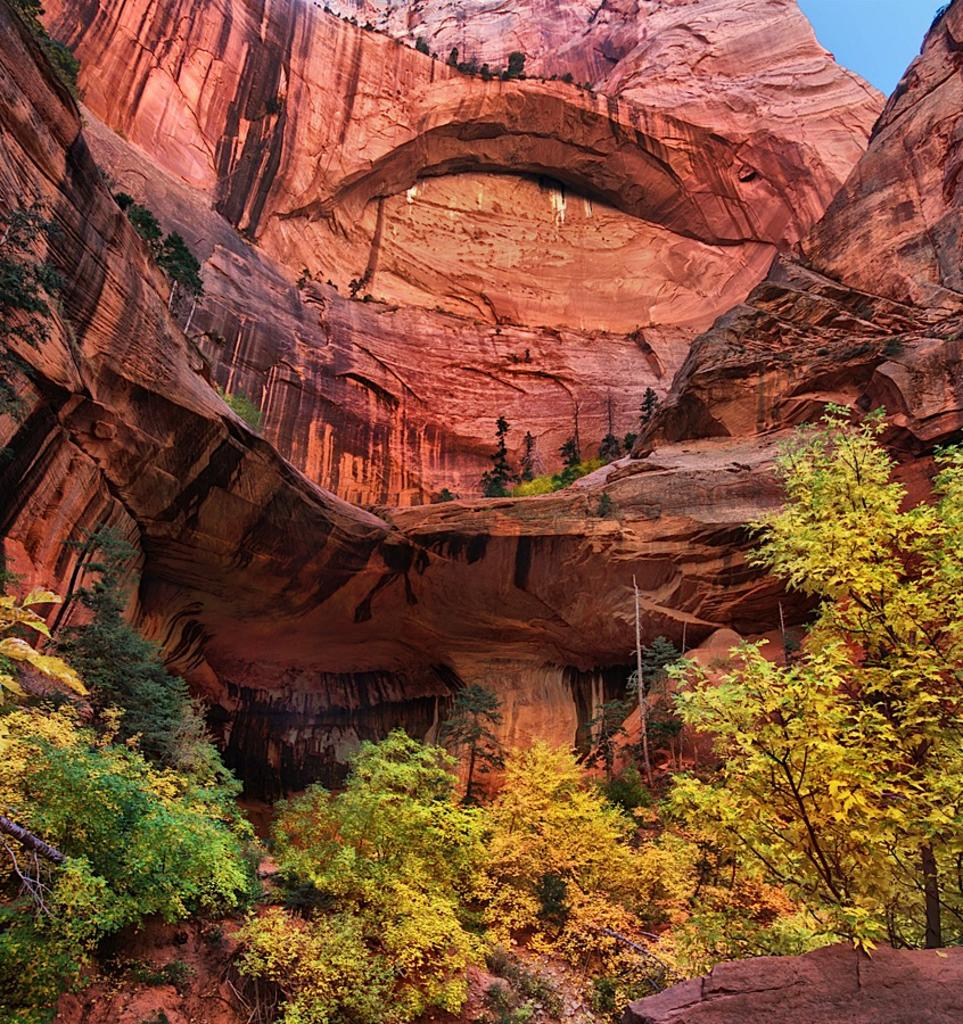What type of vegetation is visible in the front of the image? There are trees in the front of the image. What geological feature can be seen in the background of the image? There is a rock in the background of the image. What type of meat is being cooked on the campfire in the image? There is no campfire or meat present in the image; it only features trees in the front and a rock in the background. 